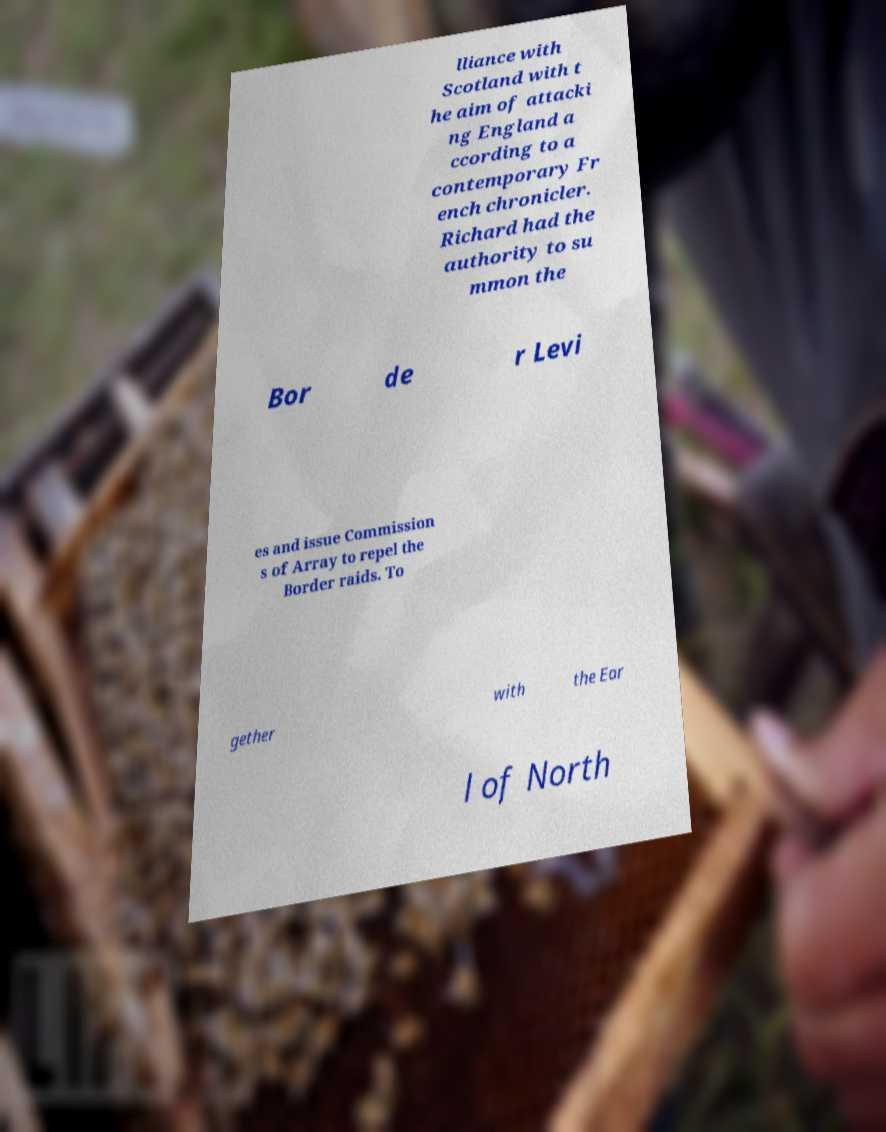Please read and relay the text visible in this image. What does it say? lliance with Scotland with t he aim of attacki ng England a ccording to a contemporary Fr ench chronicler. Richard had the authority to su mmon the Bor de r Levi es and issue Commission s of Array to repel the Border raids. To gether with the Ear l of North 